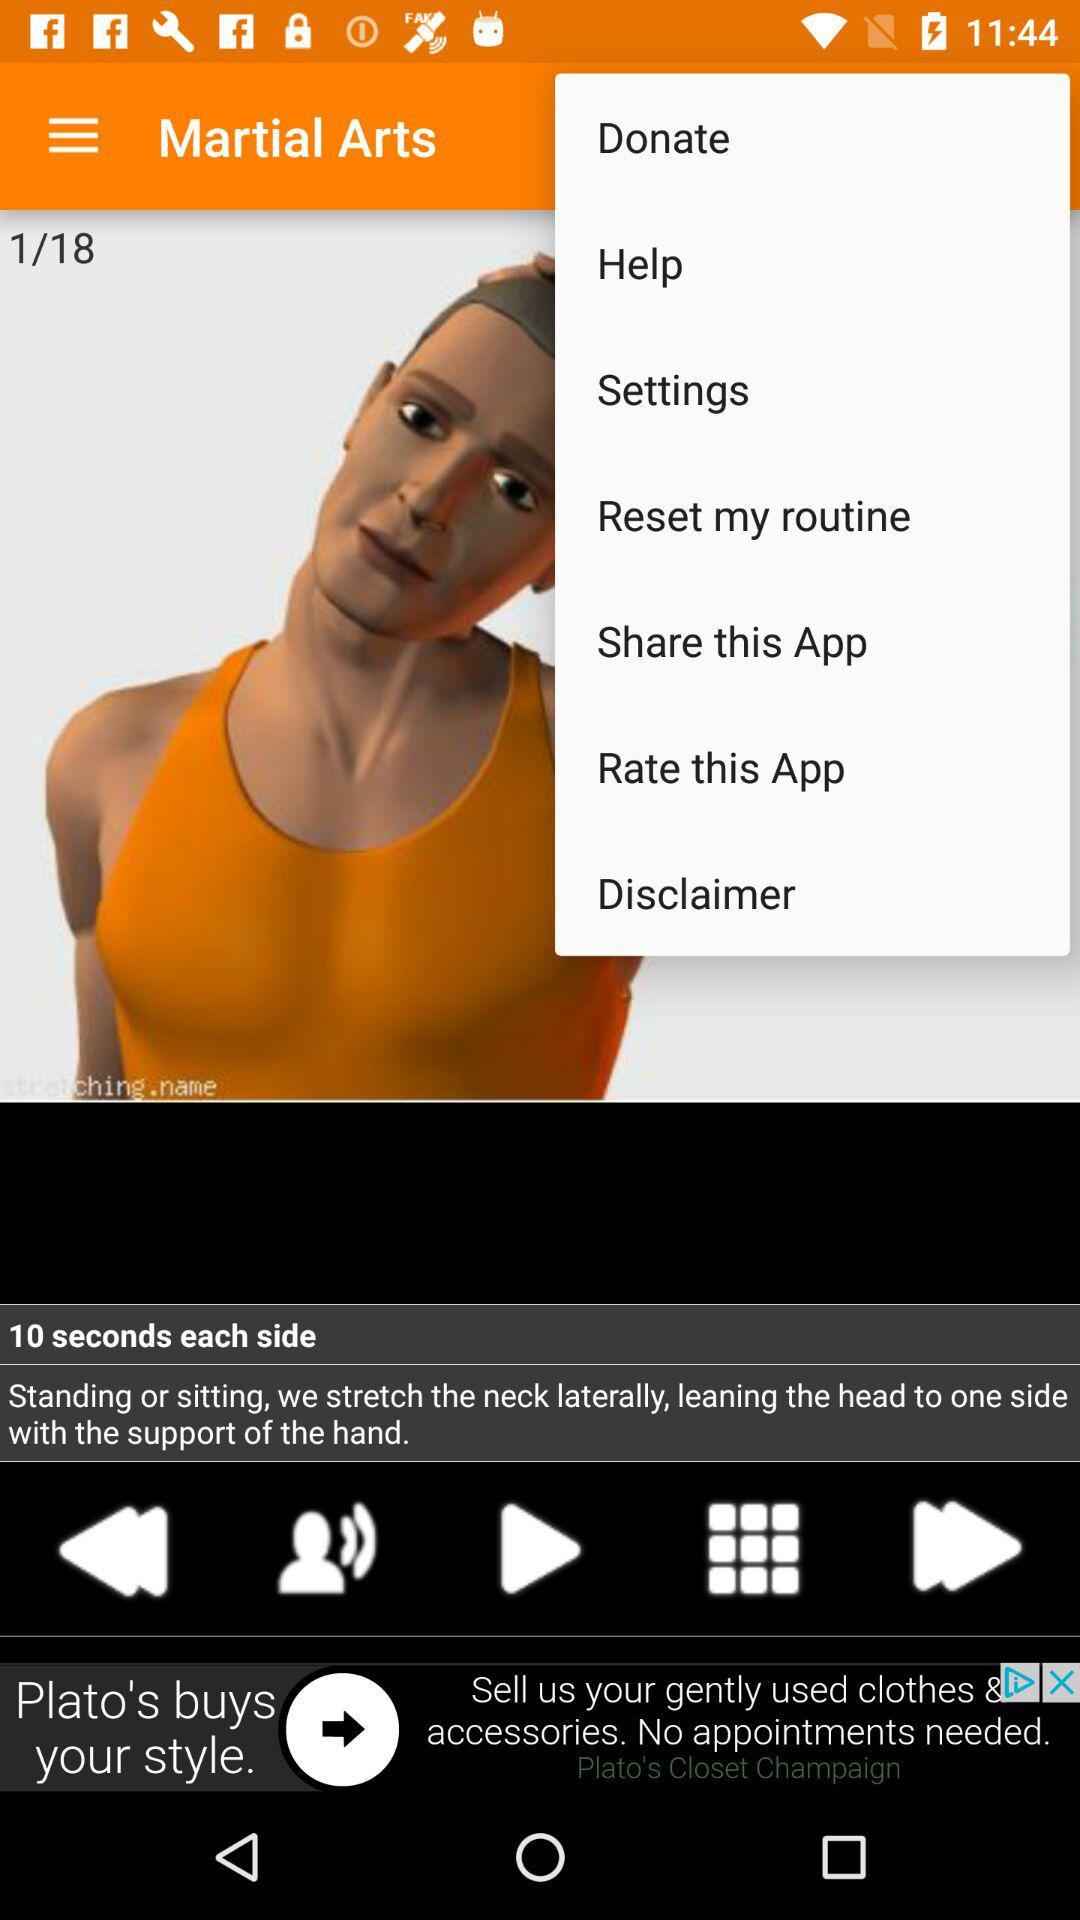How much can be donated?
When the provided information is insufficient, respond with <no answer>. <no answer> 